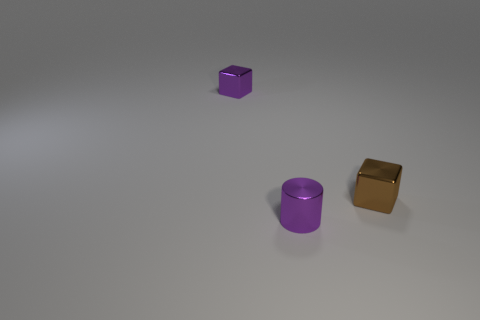Is the number of metal cubes that are in front of the purple shiny cylinder less than the number of metal things?
Make the answer very short. Yes. How many other objects are there of the same shape as the brown metallic object?
Make the answer very short. 1. Is there any other thing that has the same color as the shiny cylinder?
Your response must be concise. Yes. There is a tiny cylinder; does it have the same color as the shiny object that is right of the small purple metal cylinder?
Your answer should be very brief. No. How many other things are there of the same size as the brown metallic object?
Your answer should be compact. 2. What size is the block that is the same color as the small metal cylinder?
Your answer should be compact. Small. How many balls are tiny brown things or yellow shiny objects?
Provide a succinct answer. 0. There is a tiny purple thing to the left of the metal cylinder; is it the same shape as the brown shiny object?
Ensure brevity in your answer.  Yes. Are there more small blocks that are behind the tiny purple cube than green rubber balls?
Your answer should be compact. No. The shiny cylinder that is the same size as the brown metal cube is what color?
Your answer should be very brief. Purple. 